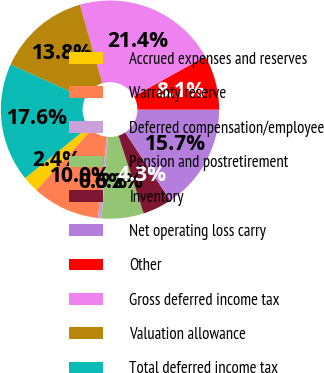<chart> <loc_0><loc_0><loc_500><loc_500><pie_chart><fcel>Accrued expenses and reserves<fcel>Warranty reserve<fcel>Deferred compensation/employee<fcel>Pension and postretirement<fcel>Inventory<fcel>Net operating loss carry<fcel>Other<fcel>Gross deferred income tax<fcel>Valuation allowance<fcel>Total deferred income tax<nl><fcel>2.43%<fcel>10.0%<fcel>0.54%<fcel>6.22%<fcel>4.33%<fcel>15.67%<fcel>8.11%<fcel>21.35%<fcel>13.78%<fcel>17.57%<nl></chart> 